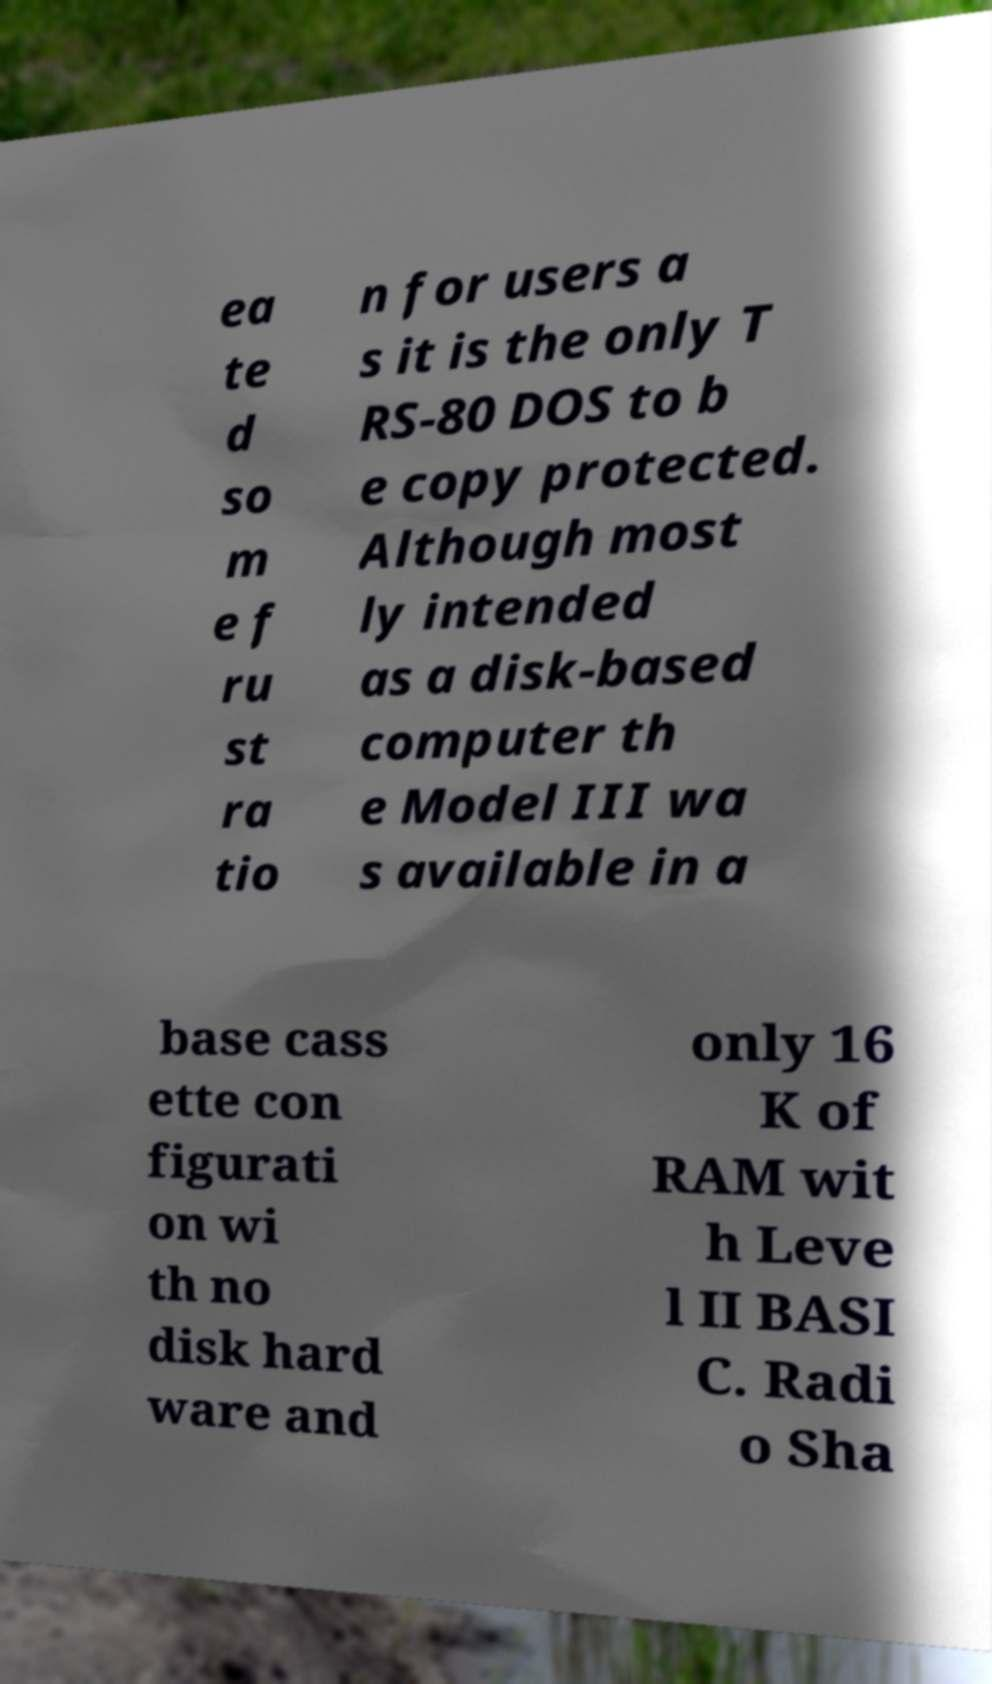Please read and relay the text visible in this image. What does it say? ea te d so m e f ru st ra tio n for users a s it is the only T RS-80 DOS to b e copy protected. Although most ly intended as a disk-based computer th e Model III wa s available in a base cass ette con figurati on wi th no disk hard ware and only 16 K of RAM wit h Leve l II BASI C. Radi o Sha 